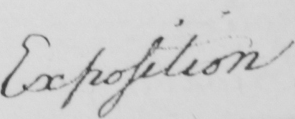What text is written in this handwritten line? Exposition 